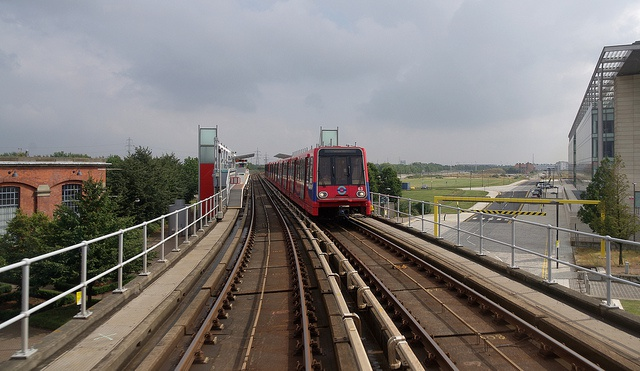Describe the objects in this image and their specific colors. I can see a train in darkgray, black, maroon, gray, and brown tones in this image. 